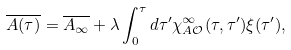Convert formula to latex. <formula><loc_0><loc_0><loc_500><loc_500>\overline { A ( \tau ) } = \overline { A _ { \infty } } + \lambda \int _ { 0 } ^ { \tau } d \tau ^ { \prime } \chi _ { A \mathcal { O } } ^ { \infty } ( \tau , \tau ^ { \prime } ) \xi ( \tau ^ { \prime } ) ,</formula> 